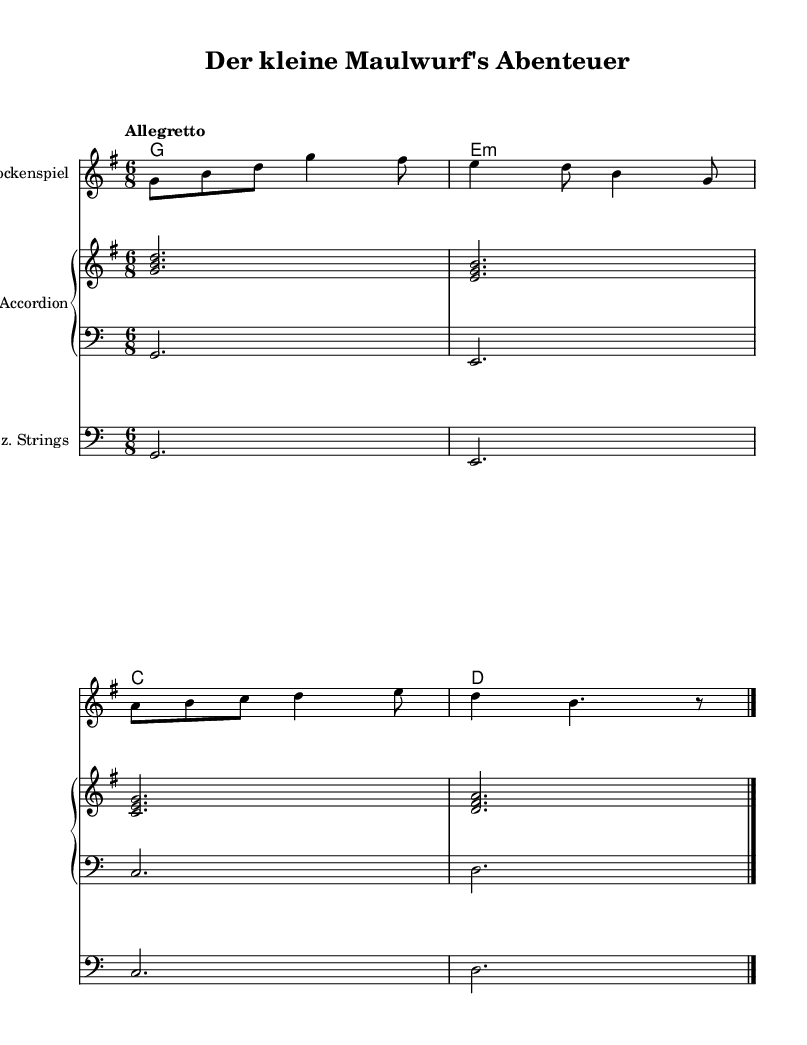What is the title of this music? The title is provided in the header, which states "Der kleine Maulwurf's Abenteuer."
Answer: Der kleine Maulwurf's Abenteuer What is the key signature of this music? The music is in G major, which is indicated by the key signature shown at the beginning of the score. It has one sharp (F#).
Answer: G major What is the time signature of this piece? The time signature appears next to the key signature and is indicated as 6/8. This tells us there are 6 eighth notes per measure.
Answer: 6/8 What is the tempo marking in this music? The tempo is indicated in the score as "Allegretto," which is a moderate tempo. This informs the performer of the speed at which to play.
Answer: Allegretto How many measures are in the melody? The melody section has 4 distinct measures, which can be counted by looking at the vertical bar lines.
Answer: 4 Which instrument plays the melody? The melody is played by the "Glockenspiel," as indicated in the instrument name above the staff where the melody is written.
Answer: Glockenspiel What type of harmony is used in this piece? The harmony is specified as "chordmode" in the score and consists of four chords: G, E minor, C, and D, which are all standard diatonic chords in the key of G major.
Answer: Chords (G, E minor, C, D) 